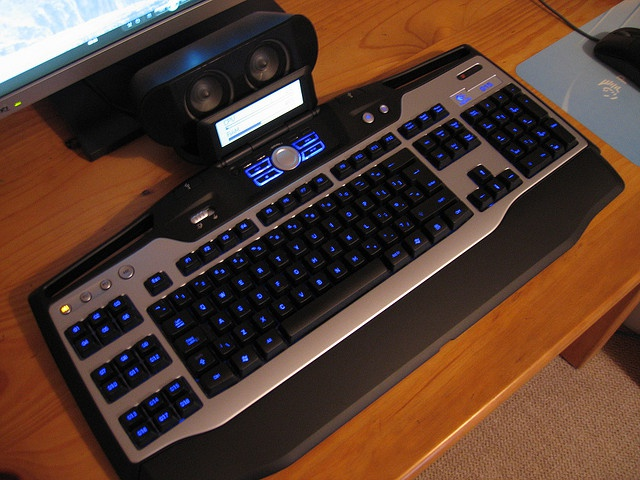Describe the objects in this image and their specific colors. I can see keyboard in lavender, black, gray, and maroon tones, tv in lightblue, black, white, and gray tones, and mouse in lavender, black, and gray tones in this image. 